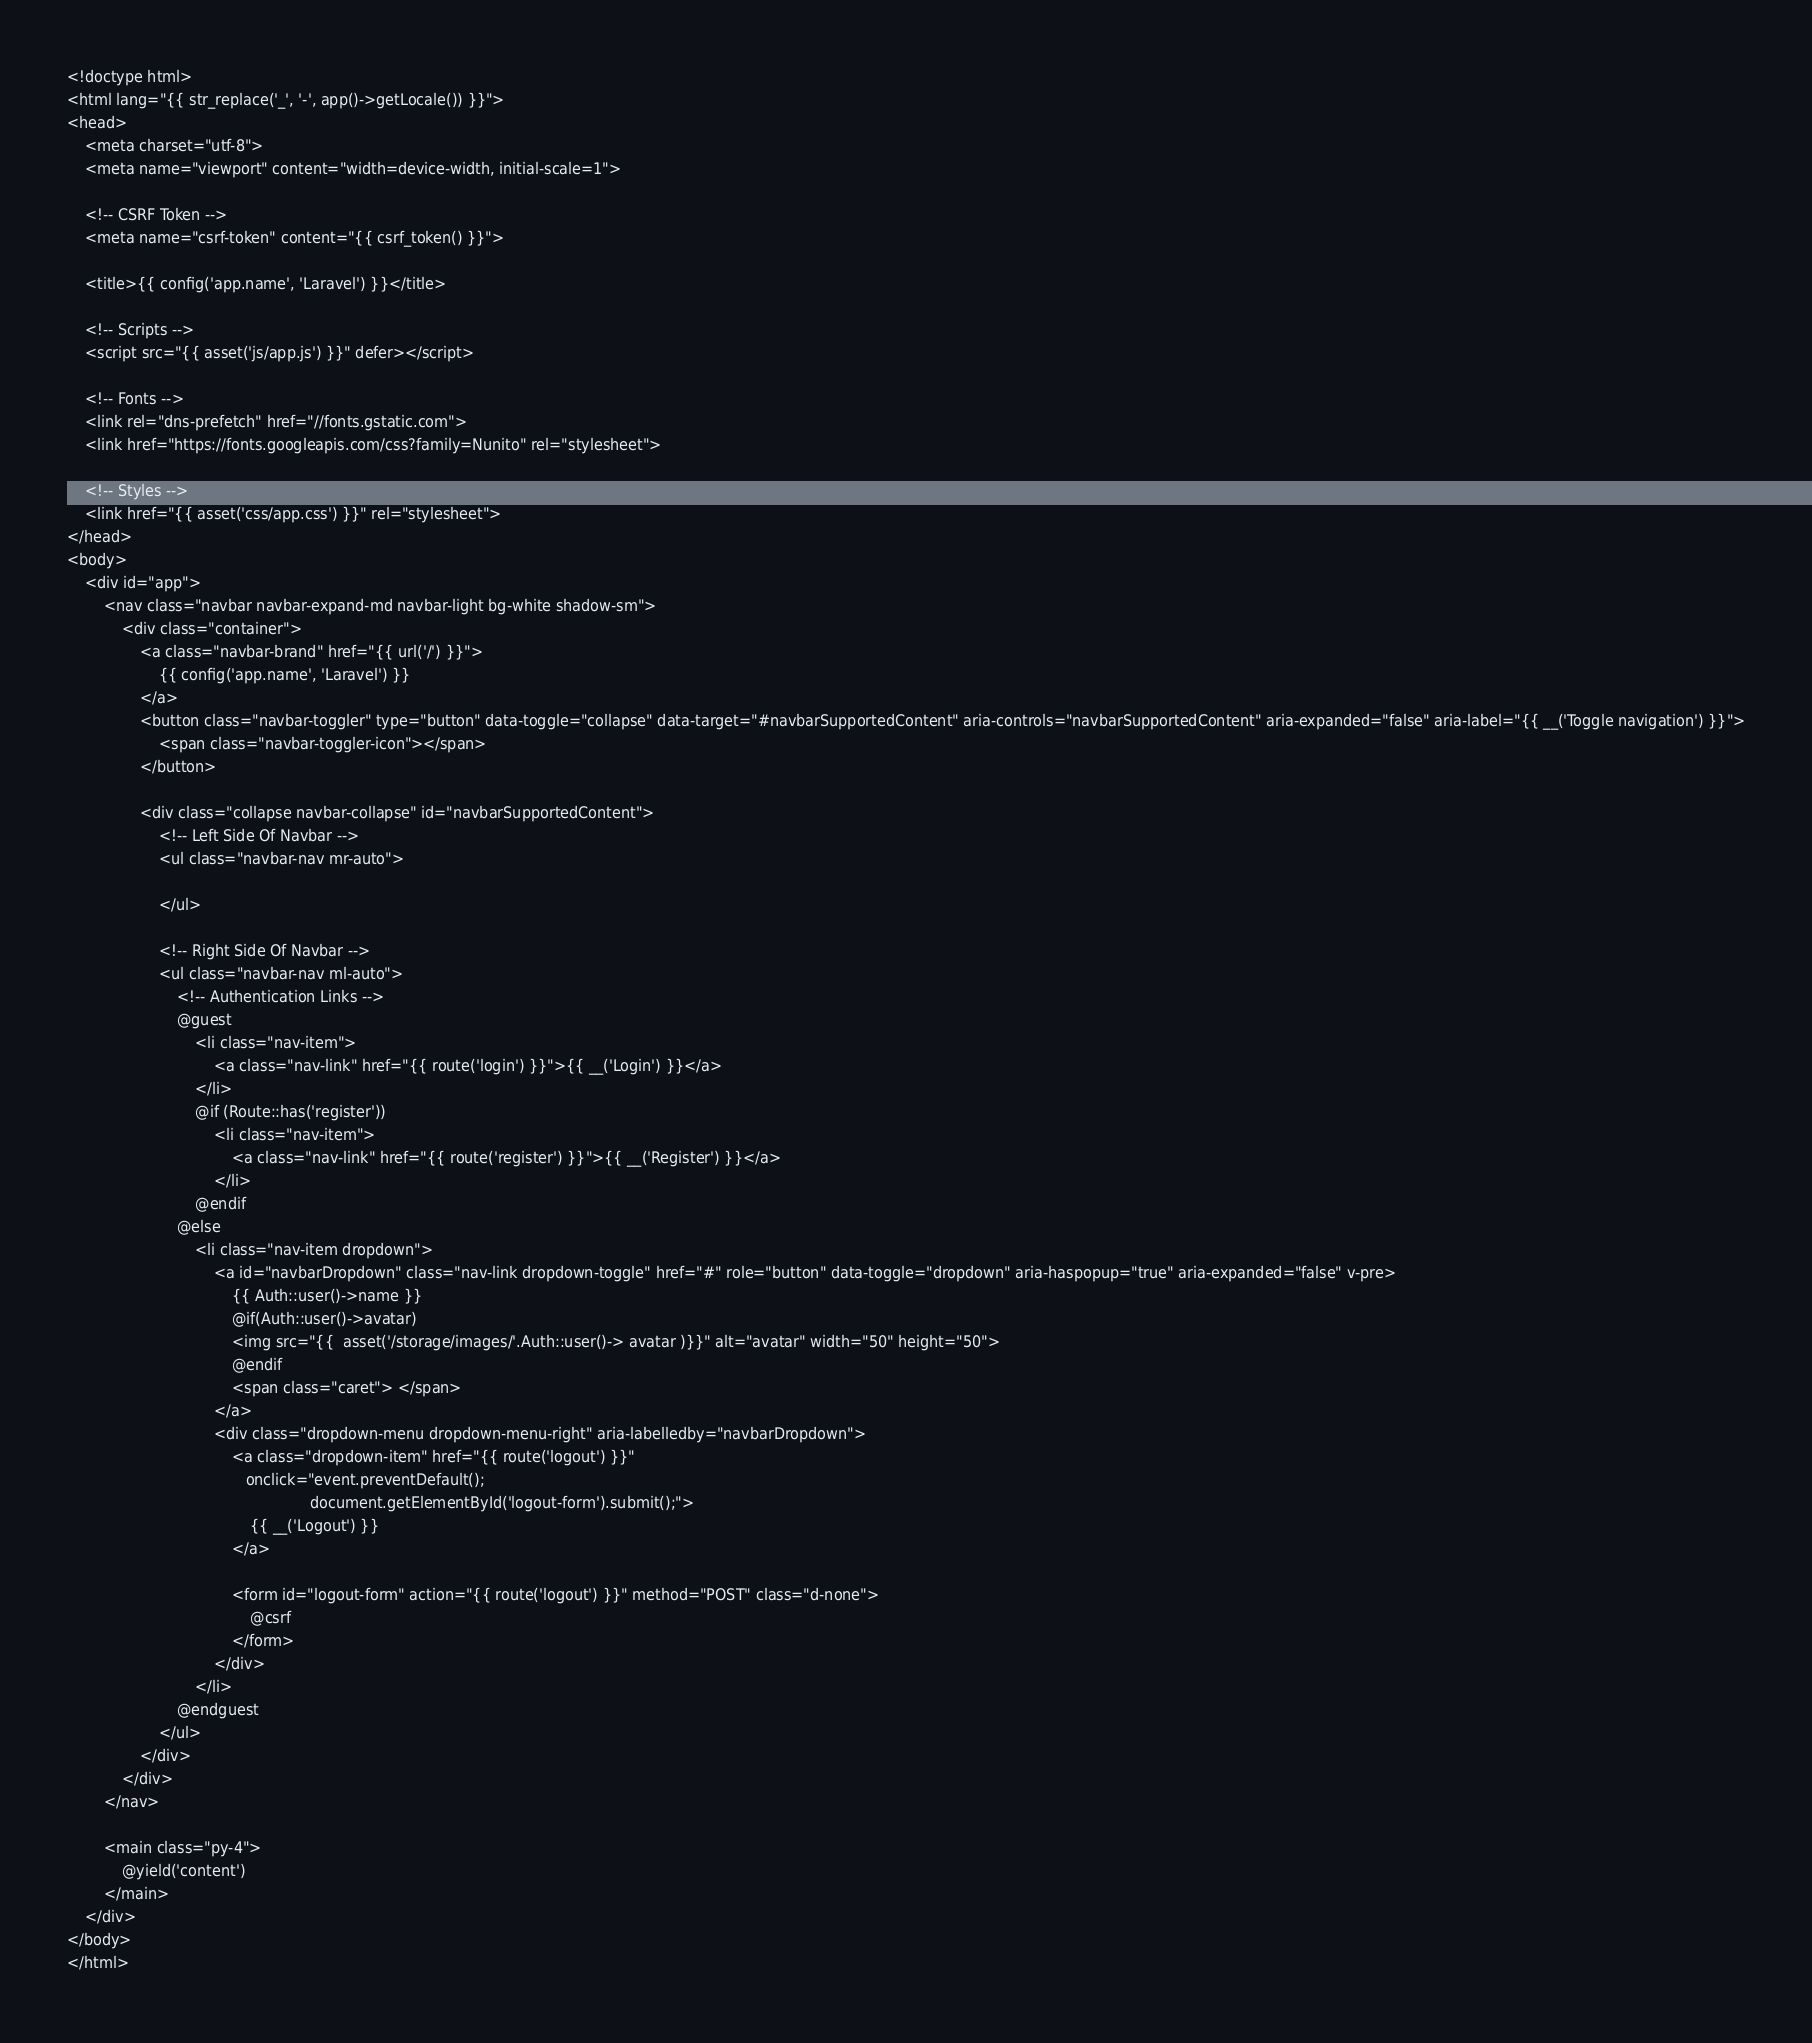Convert code to text. <code><loc_0><loc_0><loc_500><loc_500><_PHP_><!doctype html>
<html lang="{{ str_replace('_', '-', app()->getLocale()) }}">
<head>
    <meta charset="utf-8">
    <meta name="viewport" content="width=device-width, initial-scale=1">

    <!-- CSRF Token -->
    <meta name="csrf-token" content="{{ csrf_token() }}">

    <title>{{ config('app.name', 'Laravel') }}</title>

    <!-- Scripts -->
    <script src="{{ asset('js/app.js') }}" defer></script>

    <!-- Fonts -->
    <link rel="dns-prefetch" href="//fonts.gstatic.com">
    <link href="https://fonts.googleapis.com/css?family=Nunito" rel="stylesheet">

    <!-- Styles -->
    <link href="{{ asset('css/app.css') }}" rel="stylesheet">
</head>
<body>
    <div id="app">
        <nav class="navbar navbar-expand-md navbar-light bg-white shadow-sm">
            <div class="container">
                <a class="navbar-brand" href="{{ url('/') }}">
                    {{ config('app.name', 'Laravel') }}
                </a>
                <button class="navbar-toggler" type="button" data-toggle="collapse" data-target="#navbarSupportedContent" aria-controls="navbarSupportedContent" aria-expanded="false" aria-label="{{ __('Toggle navigation') }}">
                    <span class="navbar-toggler-icon"></span>
                </button>

                <div class="collapse navbar-collapse" id="navbarSupportedContent">
                    <!-- Left Side Of Navbar -->
                    <ul class="navbar-nav mr-auto">

                    </ul>

                    <!-- Right Side Of Navbar -->
                    <ul class="navbar-nav ml-auto">
                        <!-- Authentication Links -->
                        @guest
                            <li class="nav-item">
                                <a class="nav-link" href="{{ route('login') }}">{{ __('Login') }}</a>
                            </li>
                            @if (Route::has('register'))
                                <li class="nav-item">
                                    <a class="nav-link" href="{{ route('register') }}">{{ __('Register') }}</a>
                                </li>
                            @endif
                        @else
                            <li class="nav-item dropdown">
                                <a id="navbarDropdown" class="nav-link dropdown-toggle" href="#" role="button" data-toggle="dropdown" aria-haspopup="true" aria-expanded="false" v-pre>
                                    {{ Auth::user()->name }}
                                    @if(Auth::user()->avatar)
                                    <img src="{{  asset('/storage/images/'.Auth::user()-> avatar )}}" alt="avatar" width="50" height="50">
                                    @endif
                                    <span class="caret"> </span>
                                </a>
                                <div class="dropdown-menu dropdown-menu-right" aria-labelledby="navbarDropdown">
                                    <a class="dropdown-item" href="{{ route('logout') }}"
                                       onclick="event.preventDefault();
                                                     document.getElementById('logout-form').submit();">
                                        {{ __('Logout') }}
                                    </a>

                                    <form id="logout-form" action="{{ route('logout') }}" method="POST" class="d-none">
                                        @csrf
                                    </form>
                                </div>
                            </li>
                        @endguest
                    </ul>
                </div>
            </div>
        </nav>

        <main class="py-4">
            @yield('content')
        </main>
    </div>
</body>
</html>
</code> 